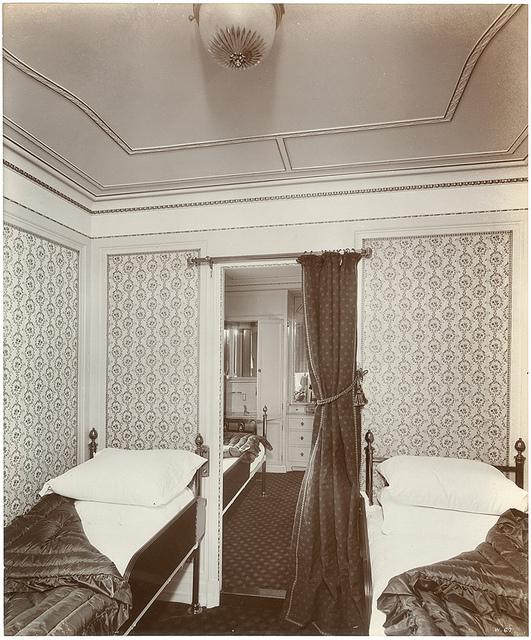Where is the light?
Quick response, please. Ceiling. What are the color of the sheets?
Be succinct. White. Does this picture have photo effects?
Quick response, please. Yes. 